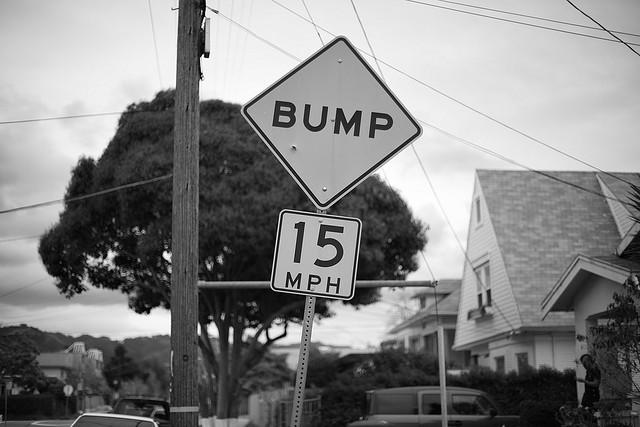What does the other sign say?
Keep it brief. 15 mph. What does the sign say about the mph sign?
Write a very short answer. 15. What is the speed limit?
Be succinct. 15. Does this look the USA?
Write a very short answer. Yes. What shape is the stop sign?
Concise answer only. Diamond. 